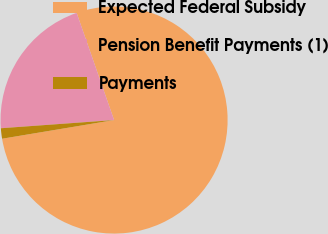Convert chart. <chart><loc_0><loc_0><loc_500><loc_500><pie_chart><fcel>Expected Federal Subsidy<fcel>Pension Benefit Payments (1)<fcel>Payments<nl><fcel>77.72%<fcel>20.8%<fcel>1.48%<nl></chart> 